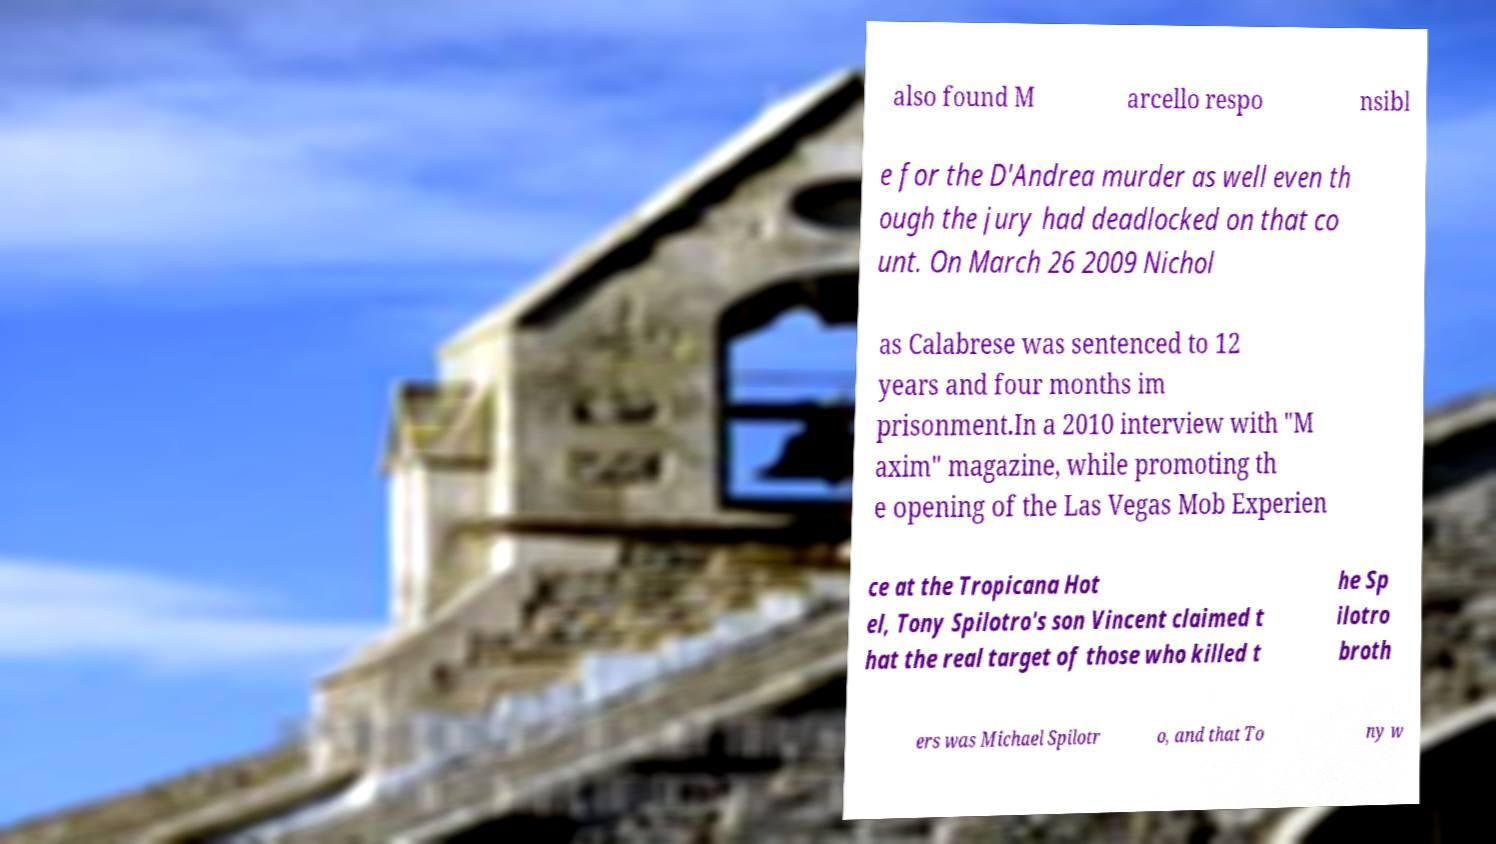I need the written content from this picture converted into text. Can you do that? also found M arcello respo nsibl e for the D'Andrea murder as well even th ough the jury had deadlocked on that co unt. On March 26 2009 Nichol as Calabrese was sentenced to 12 years and four months im prisonment.In a 2010 interview with "M axim" magazine, while promoting th e opening of the Las Vegas Mob Experien ce at the Tropicana Hot el, Tony Spilotro's son Vincent claimed t hat the real target of those who killed t he Sp ilotro broth ers was Michael Spilotr o, and that To ny w 